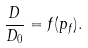Convert formula to latex. <formula><loc_0><loc_0><loc_500><loc_500>\frac { D } { D _ { 0 } } = f ( p _ { f } ) .</formula> 